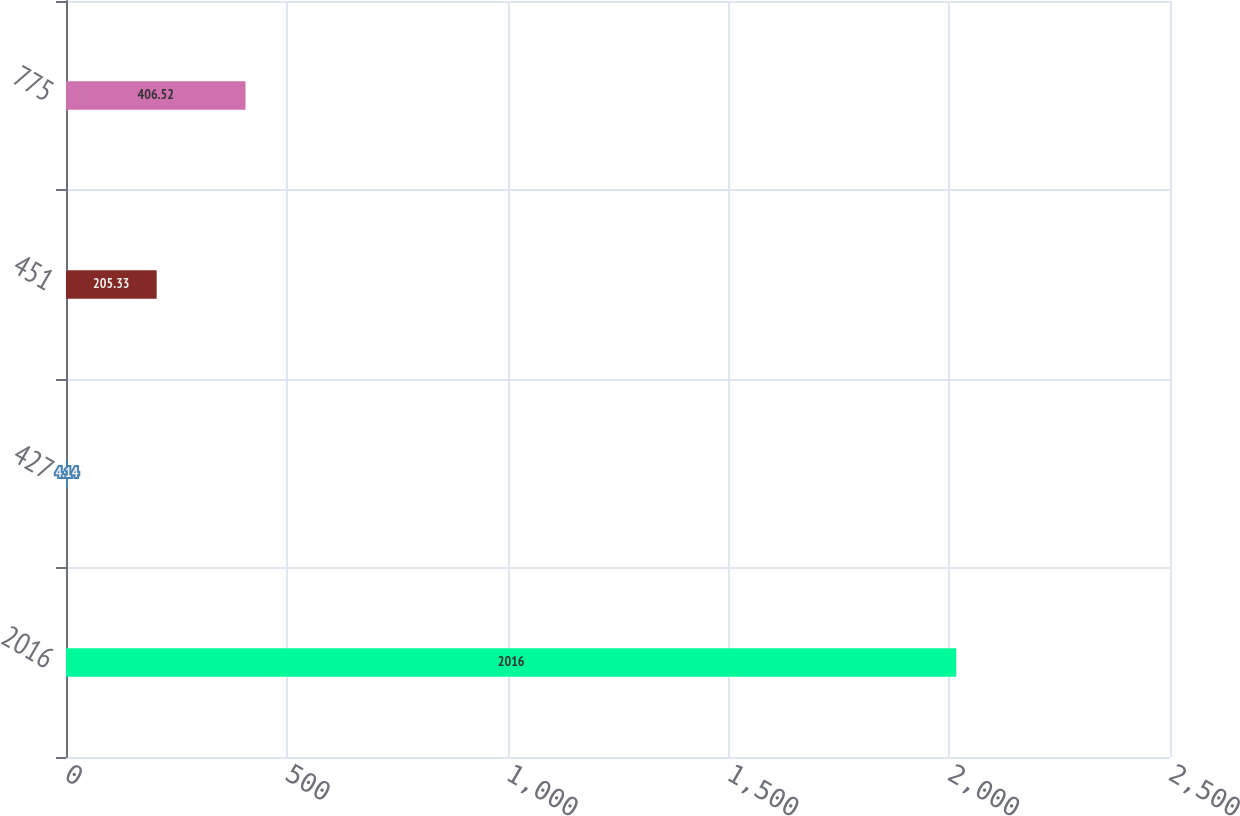<chart> <loc_0><loc_0><loc_500><loc_500><bar_chart><fcel>2016<fcel>427<fcel>451<fcel>775<nl><fcel>2016<fcel>4.14<fcel>205.33<fcel>406.52<nl></chart> 